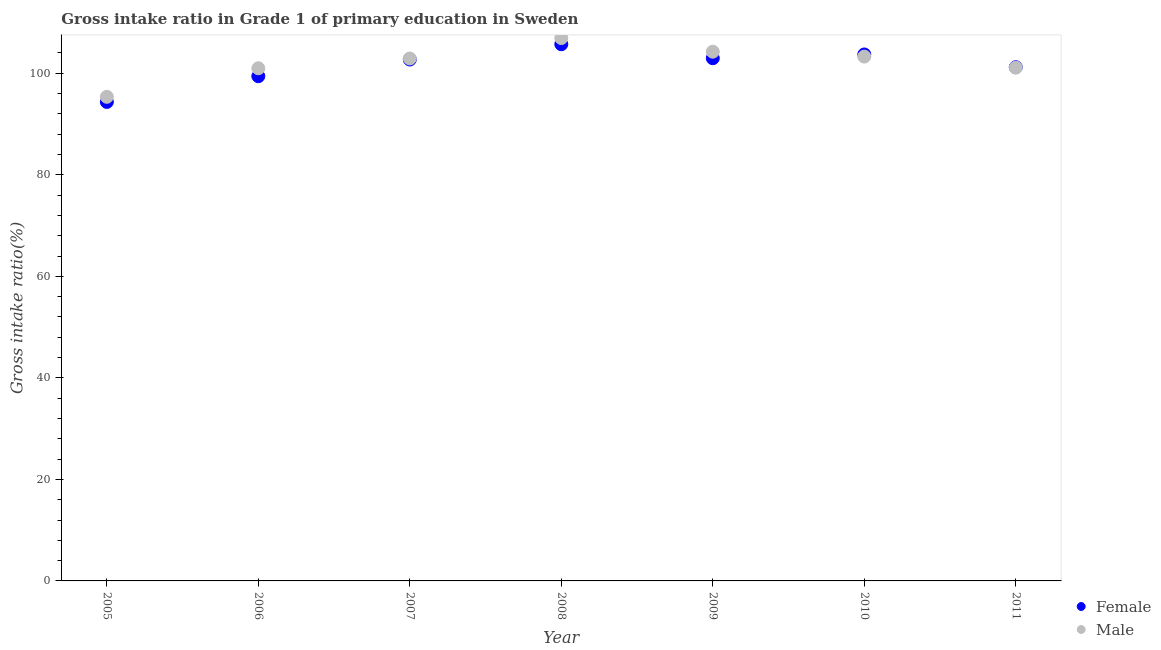How many different coloured dotlines are there?
Provide a succinct answer. 2. Is the number of dotlines equal to the number of legend labels?
Your answer should be compact. Yes. What is the gross intake ratio(male) in 2006?
Offer a very short reply. 100.99. Across all years, what is the maximum gross intake ratio(female)?
Provide a succinct answer. 105.72. Across all years, what is the minimum gross intake ratio(female)?
Make the answer very short. 94.36. In which year was the gross intake ratio(male) maximum?
Offer a terse response. 2008. What is the total gross intake ratio(female) in the graph?
Ensure brevity in your answer.  710.09. What is the difference between the gross intake ratio(male) in 2007 and that in 2011?
Offer a very short reply. 1.79. What is the difference between the gross intake ratio(male) in 2006 and the gross intake ratio(female) in 2005?
Keep it short and to the point. 6.63. What is the average gross intake ratio(female) per year?
Give a very brief answer. 101.44. In the year 2007, what is the difference between the gross intake ratio(female) and gross intake ratio(male)?
Give a very brief answer. -0.2. What is the ratio of the gross intake ratio(female) in 2005 to that in 2010?
Give a very brief answer. 0.91. Is the gross intake ratio(female) in 2005 less than that in 2009?
Your response must be concise. Yes. What is the difference between the highest and the second highest gross intake ratio(female)?
Your answer should be compact. 2.02. What is the difference between the highest and the lowest gross intake ratio(female)?
Offer a terse response. 11.36. Does the gross intake ratio(female) monotonically increase over the years?
Provide a short and direct response. No. Is the gross intake ratio(male) strictly greater than the gross intake ratio(female) over the years?
Provide a succinct answer. No. Is the gross intake ratio(female) strictly less than the gross intake ratio(male) over the years?
Your answer should be compact. No. How many dotlines are there?
Offer a very short reply. 2. What is the difference between two consecutive major ticks on the Y-axis?
Provide a short and direct response. 20. Does the graph contain any zero values?
Your response must be concise. No. Does the graph contain grids?
Your response must be concise. No. How many legend labels are there?
Offer a very short reply. 2. What is the title of the graph?
Your answer should be compact. Gross intake ratio in Grade 1 of primary education in Sweden. Does "Investments" appear as one of the legend labels in the graph?
Provide a succinct answer. No. What is the label or title of the Y-axis?
Make the answer very short. Gross intake ratio(%). What is the Gross intake ratio(%) of Female in 2005?
Offer a terse response. 94.36. What is the Gross intake ratio(%) in Male in 2005?
Offer a terse response. 95.37. What is the Gross intake ratio(%) of Female in 2006?
Your answer should be compact. 99.43. What is the Gross intake ratio(%) of Male in 2006?
Give a very brief answer. 100.99. What is the Gross intake ratio(%) of Female in 2007?
Make the answer very short. 102.71. What is the Gross intake ratio(%) of Male in 2007?
Your response must be concise. 102.91. What is the Gross intake ratio(%) in Female in 2008?
Provide a succinct answer. 105.72. What is the Gross intake ratio(%) of Male in 2008?
Make the answer very short. 106.94. What is the Gross intake ratio(%) in Female in 2009?
Provide a short and direct response. 102.97. What is the Gross intake ratio(%) of Male in 2009?
Provide a succinct answer. 104.25. What is the Gross intake ratio(%) of Female in 2010?
Keep it short and to the point. 103.71. What is the Gross intake ratio(%) in Male in 2010?
Provide a short and direct response. 103.29. What is the Gross intake ratio(%) in Female in 2011?
Your answer should be very brief. 101.2. What is the Gross intake ratio(%) of Male in 2011?
Your response must be concise. 101.12. Across all years, what is the maximum Gross intake ratio(%) of Female?
Provide a short and direct response. 105.72. Across all years, what is the maximum Gross intake ratio(%) in Male?
Keep it short and to the point. 106.94. Across all years, what is the minimum Gross intake ratio(%) of Female?
Make the answer very short. 94.36. Across all years, what is the minimum Gross intake ratio(%) in Male?
Your answer should be compact. 95.37. What is the total Gross intake ratio(%) in Female in the graph?
Keep it short and to the point. 710.09. What is the total Gross intake ratio(%) of Male in the graph?
Offer a very short reply. 714.87. What is the difference between the Gross intake ratio(%) of Female in 2005 and that in 2006?
Your answer should be compact. -5.07. What is the difference between the Gross intake ratio(%) of Male in 2005 and that in 2006?
Offer a terse response. -5.62. What is the difference between the Gross intake ratio(%) in Female in 2005 and that in 2007?
Give a very brief answer. -8.35. What is the difference between the Gross intake ratio(%) in Male in 2005 and that in 2007?
Provide a short and direct response. -7.55. What is the difference between the Gross intake ratio(%) of Female in 2005 and that in 2008?
Your answer should be very brief. -11.36. What is the difference between the Gross intake ratio(%) in Male in 2005 and that in 2008?
Give a very brief answer. -11.57. What is the difference between the Gross intake ratio(%) of Female in 2005 and that in 2009?
Give a very brief answer. -8.61. What is the difference between the Gross intake ratio(%) of Male in 2005 and that in 2009?
Ensure brevity in your answer.  -8.89. What is the difference between the Gross intake ratio(%) in Female in 2005 and that in 2010?
Make the answer very short. -9.35. What is the difference between the Gross intake ratio(%) of Male in 2005 and that in 2010?
Provide a short and direct response. -7.92. What is the difference between the Gross intake ratio(%) of Female in 2005 and that in 2011?
Give a very brief answer. -6.84. What is the difference between the Gross intake ratio(%) in Male in 2005 and that in 2011?
Offer a terse response. -5.75. What is the difference between the Gross intake ratio(%) of Female in 2006 and that in 2007?
Ensure brevity in your answer.  -3.28. What is the difference between the Gross intake ratio(%) in Male in 2006 and that in 2007?
Your answer should be very brief. -1.92. What is the difference between the Gross intake ratio(%) in Female in 2006 and that in 2008?
Give a very brief answer. -6.3. What is the difference between the Gross intake ratio(%) of Male in 2006 and that in 2008?
Offer a terse response. -5.95. What is the difference between the Gross intake ratio(%) of Female in 2006 and that in 2009?
Your answer should be compact. -3.54. What is the difference between the Gross intake ratio(%) of Male in 2006 and that in 2009?
Your response must be concise. -3.26. What is the difference between the Gross intake ratio(%) of Female in 2006 and that in 2010?
Offer a very short reply. -4.28. What is the difference between the Gross intake ratio(%) in Male in 2006 and that in 2010?
Your answer should be compact. -2.3. What is the difference between the Gross intake ratio(%) in Female in 2006 and that in 2011?
Provide a succinct answer. -1.77. What is the difference between the Gross intake ratio(%) in Male in 2006 and that in 2011?
Provide a short and direct response. -0.13. What is the difference between the Gross intake ratio(%) of Female in 2007 and that in 2008?
Offer a very short reply. -3.02. What is the difference between the Gross intake ratio(%) of Male in 2007 and that in 2008?
Offer a very short reply. -4.03. What is the difference between the Gross intake ratio(%) of Female in 2007 and that in 2009?
Offer a terse response. -0.26. What is the difference between the Gross intake ratio(%) in Male in 2007 and that in 2009?
Offer a terse response. -1.34. What is the difference between the Gross intake ratio(%) of Female in 2007 and that in 2010?
Ensure brevity in your answer.  -1. What is the difference between the Gross intake ratio(%) of Male in 2007 and that in 2010?
Your answer should be compact. -0.38. What is the difference between the Gross intake ratio(%) of Female in 2007 and that in 2011?
Offer a very short reply. 1.51. What is the difference between the Gross intake ratio(%) in Male in 2007 and that in 2011?
Keep it short and to the point. 1.79. What is the difference between the Gross intake ratio(%) of Female in 2008 and that in 2009?
Offer a terse response. 2.75. What is the difference between the Gross intake ratio(%) in Male in 2008 and that in 2009?
Provide a succinct answer. 2.69. What is the difference between the Gross intake ratio(%) of Female in 2008 and that in 2010?
Offer a terse response. 2.02. What is the difference between the Gross intake ratio(%) in Male in 2008 and that in 2010?
Offer a terse response. 3.65. What is the difference between the Gross intake ratio(%) of Female in 2008 and that in 2011?
Offer a very short reply. 4.52. What is the difference between the Gross intake ratio(%) in Male in 2008 and that in 2011?
Provide a succinct answer. 5.82. What is the difference between the Gross intake ratio(%) in Female in 2009 and that in 2010?
Provide a succinct answer. -0.74. What is the difference between the Gross intake ratio(%) in Male in 2009 and that in 2010?
Give a very brief answer. 0.96. What is the difference between the Gross intake ratio(%) of Female in 2009 and that in 2011?
Your answer should be compact. 1.77. What is the difference between the Gross intake ratio(%) of Male in 2009 and that in 2011?
Provide a succinct answer. 3.13. What is the difference between the Gross intake ratio(%) of Female in 2010 and that in 2011?
Provide a succinct answer. 2.51. What is the difference between the Gross intake ratio(%) in Male in 2010 and that in 2011?
Provide a short and direct response. 2.17. What is the difference between the Gross intake ratio(%) in Female in 2005 and the Gross intake ratio(%) in Male in 2006?
Give a very brief answer. -6.63. What is the difference between the Gross intake ratio(%) in Female in 2005 and the Gross intake ratio(%) in Male in 2007?
Your answer should be compact. -8.55. What is the difference between the Gross intake ratio(%) of Female in 2005 and the Gross intake ratio(%) of Male in 2008?
Ensure brevity in your answer.  -12.58. What is the difference between the Gross intake ratio(%) of Female in 2005 and the Gross intake ratio(%) of Male in 2009?
Keep it short and to the point. -9.89. What is the difference between the Gross intake ratio(%) of Female in 2005 and the Gross intake ratio(%) of Male in 2010?
Offer a terse response. -8.93. What is the difference between the Gross intake ratio(%) of Female in 2005 and the Gross intake ratio(%) of Male in 2011?
Ensure brevity in your answer.  -6.76. What is the difference between the Gross intake ratio(%) of Female in 2006 and the Gross intake ratio(%) of Male in 2007?
Your answer should be compact. -3.48. What is the difference between the Gross intake ratio(%) in Female in 2006 and the Gross intake ratio(%) in Male in 2008?
Provide a short and direct response. -7.51. What is the difference between the Gross intake ratio(%) of Female in 2006 and the Gross intake ratio(%) of Male in 2009?
Provide a succinct answer. -4.82. What is the difference between the Gross intake ratio(%) in Female in 2006 and the Gross intake ratio(%) in Male in 2010?
Offer a terse response. -3.86. What is the difference between the Gross intake ratio(%) in Female in 2006 and the Gross intake ratio(%) in Male in 2011?
Ensure brevity in your answer.  -1.69. What is the difference between the Gross intake ratio(%) in Female in 2007 and the Gross intake ratio(%) in Male in 2008?
Keep it short and to the point. -4.23. What is the difference between the Gross intake ratio(%) of Female in 2007 and the Gross intake ratio(%) of Male in 2009?
Keep it short and to the point. -1.54. What is the difference between the Gross intake ratio(%) of Female in 2007 and the Gross intake ratio(%) of Male in 2010?
Give a very brief answer. -0.58. What is the difference between the Gross intake ratio(%) of Female in 2007 and the Gross intake ratio(%) of Male in 2011?
Provide a short and direct response. 1.59. What is the difference between the Gross intake ratio(%) in Female in 2008 and the Gross intake ratio(%) in Male in 2009?
Ensure brevity in your answer.  1.47. What is the difference between the Gross intake ratio(%) in Female in 2008 and the Gross intake ratio(%) in Male in 2010?
Ensure brevity in your answer.  2.43. What is the difference between the Gross intake ratio(%) of Female in 2008 and the Gross intake ratio(%) of Male in 2011?
Offer a terse response. 4.61. What is the difference between the Gross intake ratio(%) of Female in 2009 and the Gross intake ratio(%) of Male in 2010?
Your answer should be very brief. -0.32. What is the difference between the Gross intake ratio(%) of Female in 2009 and the Gross intake ratio(%) of Male in 2011?
Your response must be concise. 1.85. What is the difference between the Gross intake ratio(%) of Female in 2010 and the Gross intake ratio(%) of Male in 2011?
Give a very brief answer. 2.59. What is the average Gross intake ratio(%) in Female per year?
Provide a short and direct response. 101.44. What is the average Gross intake ratio(%) in Male per year?
Provide a short and direct response. 102.12. In the year 2005, what is the difference between the Gross intake ratio(%) of Female and Gross intake ratio(%) of Male?
Offer a terse response. -1.01. In the year 2006, what is the difference between the Gross intake ratio(%) in Female and Gross intake ratio(%) in Male?
Give a very brief answer. -1.56. In the year 2007, what is the difference between the Gross intake ratio(%) in Female and Gross intake ratio(%) in Male?
Give a very brief answer. -0.2. In the year 2008, what is the difference between the Gross intake ratio(%) of Female and Gross intake ratio(%) of Male?
Your response must be concise. -1.21. In the year 2009, what is the difference between the Gross intake ratio(%) in Female and Gross intake ratio(%) in Male?
Provide a succinct answer. -1.28. In the year 2010, what is the difference between the Gross intake ratio(%) in Female and Gross intake ratio(%) in Male?
Your answer should be very brief. 0.42. In the year 2011, what is the difference between the Gross intake ratio(%) in Female and Gross intake ratio(%) in Male?
Your response must be concise. 0.08. What is the ratio of the Gross intake ratio(%) of Female in 2005 to that in 2006?
Your answer should be very brief. 0.95. What is the ratio of the Gross intake ratio(%) in Male in 2005 to that in 2006?
Offer a very short reply. 0.94. What is the ratio of the Gross intake ratio(%) in Female in 2005 to that in 2007?
Make the answer very short. 0.92. What is the ratio of the Gross intake ratio(%) of Male in 2005 to that in 2007?
Offer a very short reply. 0.93. What is the ratio of the Gross intake ratio(%) of Female in 2005 to that in 2008?
Provide a succinct answer. 0.89. What is the ratio of the Gross intake ratio(%) in Male in 2005 to that in 2008?
Your answer should be compact. 0.89. What is the ratio of the Gross intake ratio(%) of Female in 2005 to that in 2009?
Your answer should be very brief. 0.92. What is the ratio of the Gross intake ratio(%) in Male in 2005 to that in 2009?
Offer a very short reply. 0.91. What is the ratio of the Gross intake ratio(%) of Female in 2005 to that in 2010?
Offer a terse response. 0.91. What is the ratio of the Gross intake ratio(%) in Male in 2005 to that in 2010?
Ensure brevity in your answer.  0.92. What is the ratio of the Gross intake ratio(%) in Female in 2005 to that in 2011?
Keep it short and to the point. 0.93. What is the ratio of the Gross intake ratio(%) in Male in 2005 to that in 2011?
Ensure brevity in your answer.  0.94. What is the ratio of the Gross intake ratio(%) of Female in 2006 to that in 2007?
Your answer should be very brief. 0.97. What is the ratio of the Gross intake ratio(%) in Male in 2006 to that in 2007?
Make the answer very short. 0.98. What is the ratio of the Gross intake ratio(%) of Female in 2006 to that in 2008?
Provide a short and direct response. 0.94. What is the ratio of the Gross intake ratio(%) of Male in 2006 to that in 2008?
Provide a succinct answer. 0.94. What is the ratio of the Gross intake ratio(%) of Female in 2006 to that in 2009?
Your answer should be very brief. 0.97. What is the ratio of the Gross intake ratio(%) of Male in 2006 to that in 2009?
Give a very brief answer. 0.97. What is the ratio of the Gross intake ratio(%) in Female in 2006 to that in 2010?
Offer a terse response. 0.96. What is the ratio of the Gross intake ratio(%) in Male in 2006 to that in 2010?
Your answer should be compact. 0.98. What is the ratio of the Gross intake ratio(%) in Female in 2006 to that in 2011?
Make the answer very short. 0.98. What is the ratio of the Gross intake ratio(%) in Male in 2006 to that in 2011?
Ensure brevity in your answer.  1. What is the ratio of the Gross intake ratio(%) in Female in 2007 to that in 2008?
Make the answer very short. 0.97. What is the ratio of the Gross intake ratio(%) in Male in 2007 to that in 2008?
Keep it short and to the point. 0.96. What is the ratio of the Gross intake ratio(%) in Female in 2007 to that in 2009?
Your answer should be compact. 1. What is the ratio of the Gross intake ratio(%) of Male in 2007 to that in 2009?
Your answer should be compact. 0.99. What is the ratio of the Gross intake ratio(%) in Female in 2007 to that in 2010?
Offer a very short reply. 0.99. What is the ratio of the Gross intake ratio(%) in Female in 2007 to that in 2011?
Your answer should be compact. 1.01. What is the ratio of the Gross intake ratio(%) of Male in 2007 to that in 2011?
Provide a succinct answer. 1.02. What is the ratio of the Gross intake ratio(%) of Female in 2008 to that in 2009?
Your answer should be very brief. 1.03. What is the ratio of the Gross intake ratio(%) in Male in 2008 to that in 2009?
Give a very brief answer. 1.03. What is the ratio of the Gross intake ratio(%) of Female in 2008 to that in 2010?
Keep it short and to the point. 1.02. What is the ratio of the Gross intake ratio(%) in Male in 2008 to that in 2010?
Give a very brief answer. 1.04. What is the ratio of the Gross intake ratio(%) in Female in 2008 to that in 2011?
Provide a succinct answer. 1.04. What is the ratio of the Gross intake ratio(%) in Male in 2008 to that in 2011?
Make the answer very short. 1.06. What is the ratio of the Gross intake ratio(%) of Female in 2009 to that in 2010?
Make the answer very short. 0.99. What is the ratio of the Gross intake ratio(%) in Male in 2009 to that in 2010?
Your response must be concise. 1.01. What is the ratio of the Gross intake ratio(%) of Female in 2009 to that in 2011?
Offer a very short reply. 1.02. What is the ratio of the Gross intake ratio(%) of Male in 2009 to that in 2011?
Your response must be concise. 1.03. What is the ratio of the Gross intake ratio(%) in Female in 2010 to that in 2011?
Keep it short and to the point. 1.02. What is the ratio of the Gross intake ratio(%) in Male in 2010 to that in 2011?
Offer a very short reply. 1.02. What is the difference between the highest and the second highest Gross intake ratio(%) in Female?
Provide a succinct answer. 2.02. What is the difference between the highest and the second highest Gross intake ratio(%) in Male?
Make the answer very short. 2.69. What is the difference between the highest and the lowest Gross intake ratio(%) of Female?
Your answer should be compact. 11.36. What is the difference between the highest and the lowest Gross intake ratio(%) in Male?
Provide a short and direct response. 11.57. 